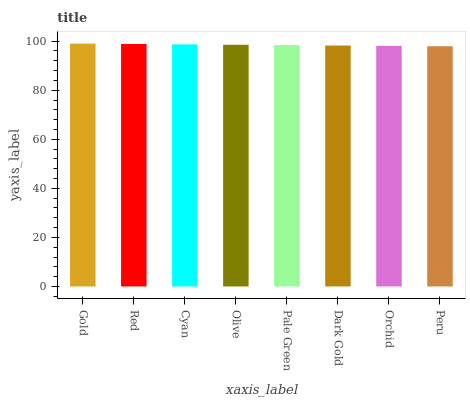Is Peru the minimum?
Answer yes or no. Yes. Is Gold the maximum?
Answer yes or no. Yes. Is Red the minimum?
Answer yes or no. No. Is Red the maximum?
Answer yes or no. No. Is Gold greater than Red?
Answer yes or no. Yes. Is Red less than Gold?
Answer yes or no. Yes. Is Red greater than Gold?
Answer yes or no. No. Is Gold less than Red?
Answer yes or no. No. Is Olive the high median?
Answer yes or no. Yes. Is Pale Green the low median?
Answer yes or no. Yes. Is Peru the high median?
Answer yes or no. No. Is Dark Gold the low median?
Answer yes or no. No. 